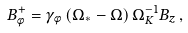Convert formula to latex. <formula><loc_0><loc_0><loc_500><loc_500>B _ { \phi } ^ { + } = \gamma _ { \phi } \left ( \Omega _ { \ast } - \Omega \right ) \Omega _ { K } ^ { - 1 } B _ { z } \, ,</formula> 